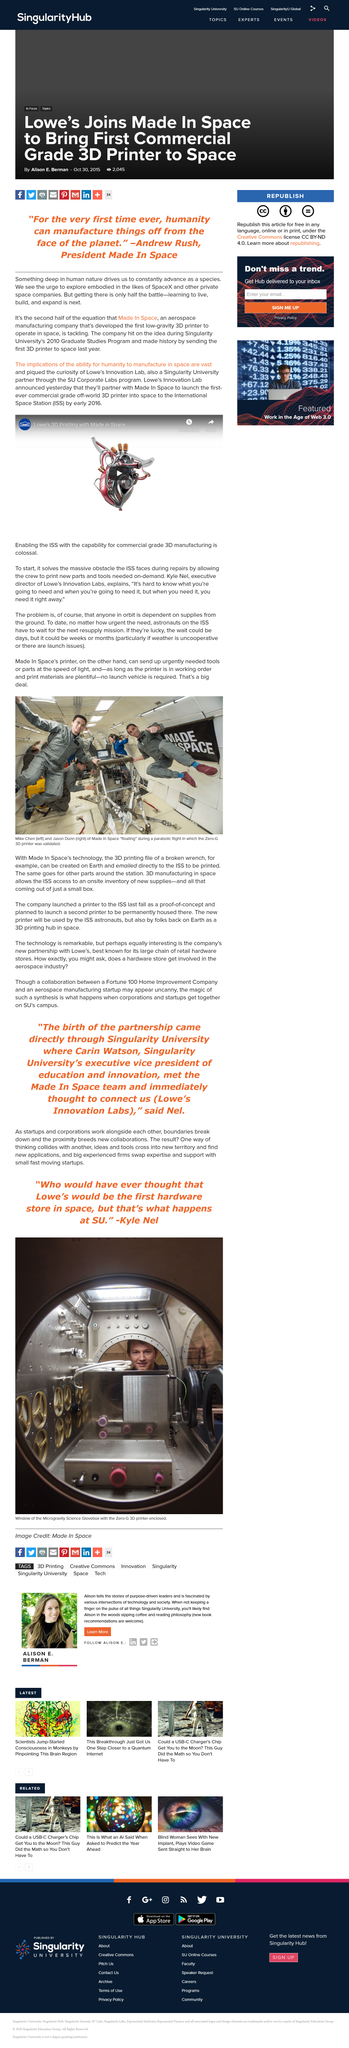Give some essential details in this illustration. Andrew Rush's Made In Space is an aerospace manufacturing company that produces high-quality parts and components through innovative and advanced manufacturing processes. We are proud to announce that the Lowe's Innovation Lab will be partnering with Made In Space to launch the first ever commercial-grade off-world 3D printer, marking a significant milestone in the field of additive manufacturing. The man on the right in the photo is named Jason Dunn, as stated in the sentence "What's the name of the man on the right in the photo? It's Jason Dunn...". It is known that Made In Space developed the first low-gravity 3D printer. The man on the left in the photo is named Mike Chen. 